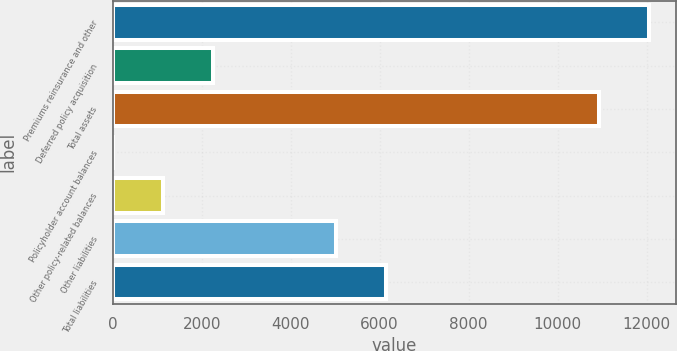<chart> <loc_0><loc_0><loc_500><loc_500><bar_chart><fcel>Premiums reinsurance and other<fcel>Deferred policy acquisition<fcel>Total assets<fcel>Policyholder account balances<fcel>Other policy-related balances<fcel>Other liabilities<fcel>Total liabilities<nl><fcel>12053.6<fcel>2252.2<fcel>10928<fcel>1<fcel>1126.6<fcel>5009<fcel>6134.6<nl></chart> 